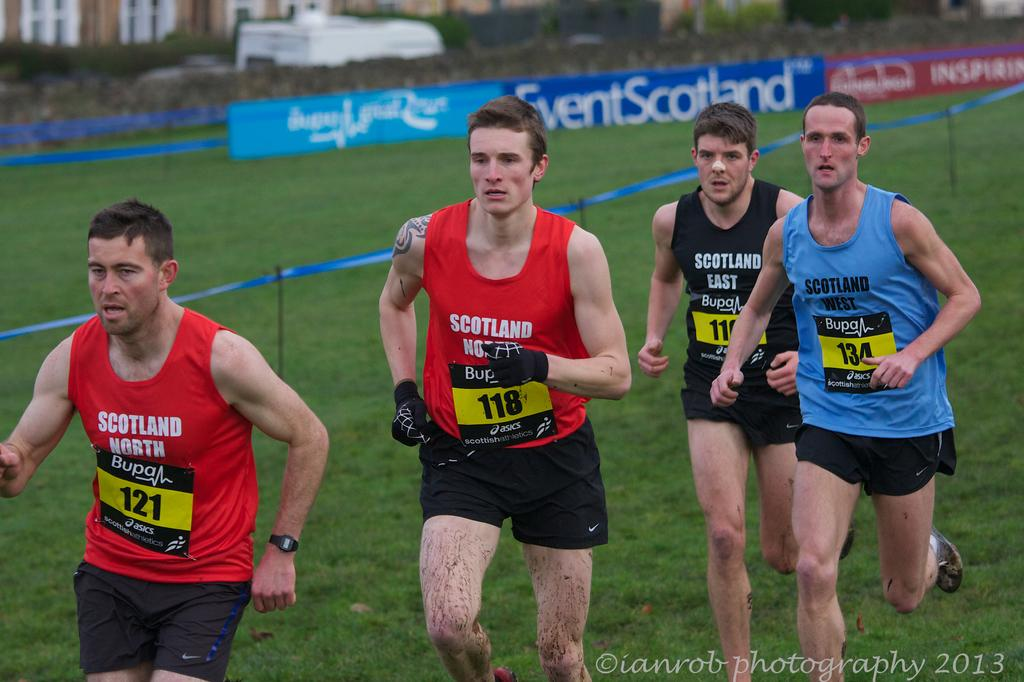What are the persons in the image doing? The persons in the image are running on the grass. What else can be seen in the image besides the persons running? There are banners visible in the image. What type of structures can be seen in the image? There are buildings in the image. What type of skin condition can be seen on the persons running in the image? There is no indication of any skin condition on the persons running in the image. How many lamps are visible in the image? There is no lamp present in the image. 